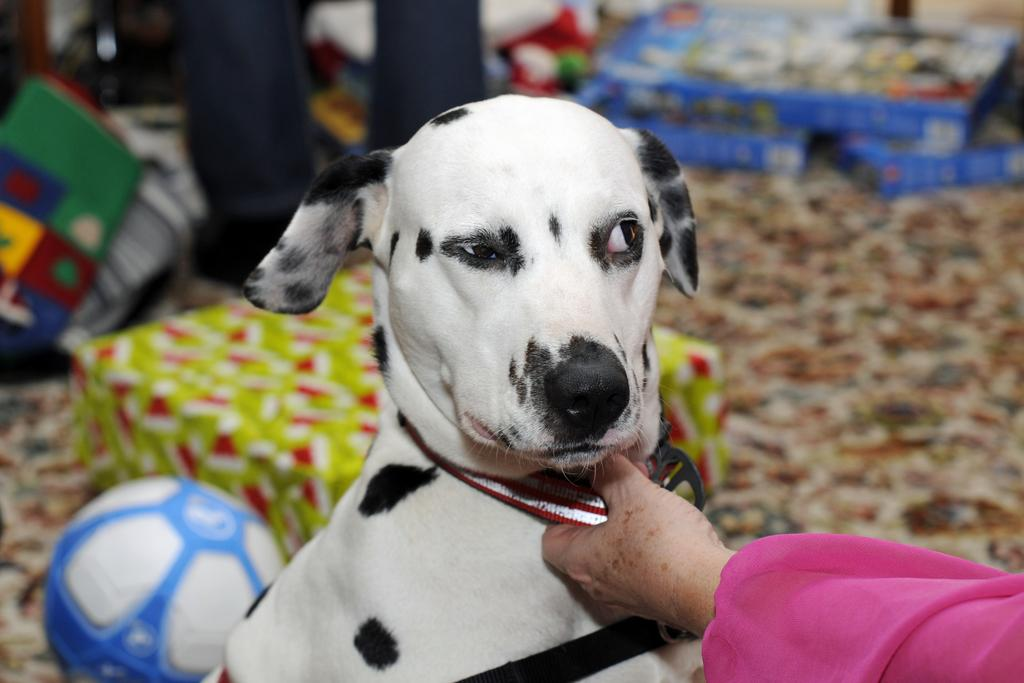Who or what is the main subject in the image? There is a person in the image. What is the person holding? The person is holding a dog. What is behind the dog? There is a ball behind the dog. What type of objects can be seen in the image besides the dog and ball? There are boxes visible in the image. Can you describe any other objects in the image? There are other unspecified objects in the image. What type of disgusting business is the person conducting in the image? There is no indication of any business or disgust in the image; it simply shows a person holding a dog with a ball behind it. 